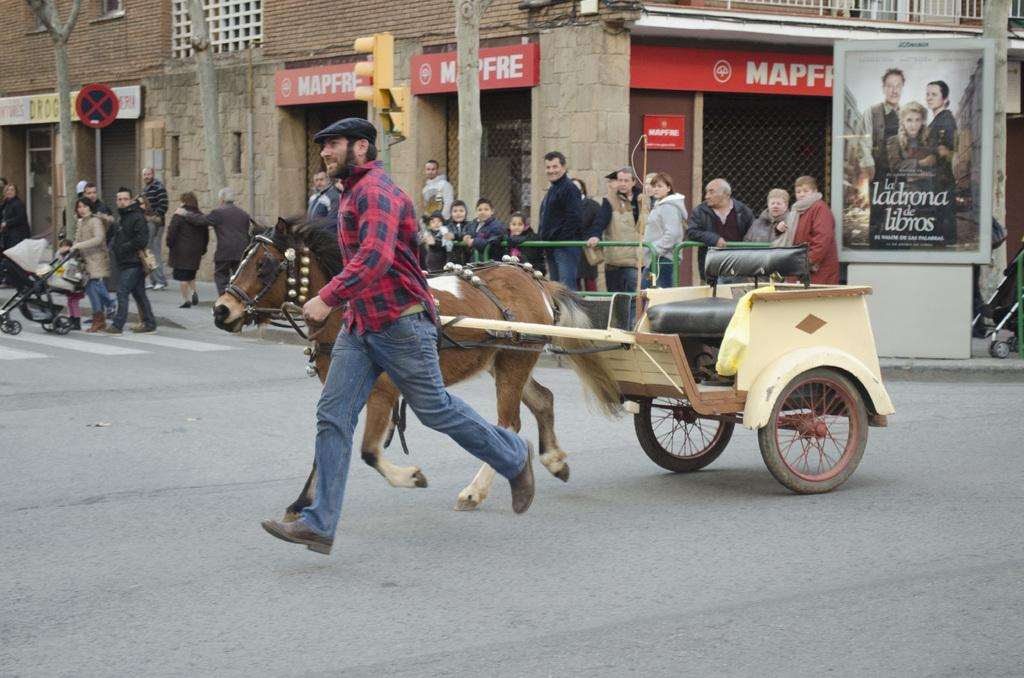How many people are in the group visible in the image? There is a group of people in the image, but the exact number cannot be determined from the provided facts. What animal is present in the image? There is a horse in the image. What can be seen in the background of the image? There are hoardings, buildings, poles, and sign boards in the background of the image. What type of zipper is being used by the horse in the image? There is no zipper present in the image, as horses do not wear clothing with zippers. 